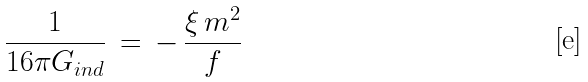<formula> <loc_0><loc_0><loc_500><loc_500>\frac { 1 } { 1 6 \pi G _ { i n d } } \, = \, - \, \frac { \xi \, m ^ { 2 } } { f }</formula> 